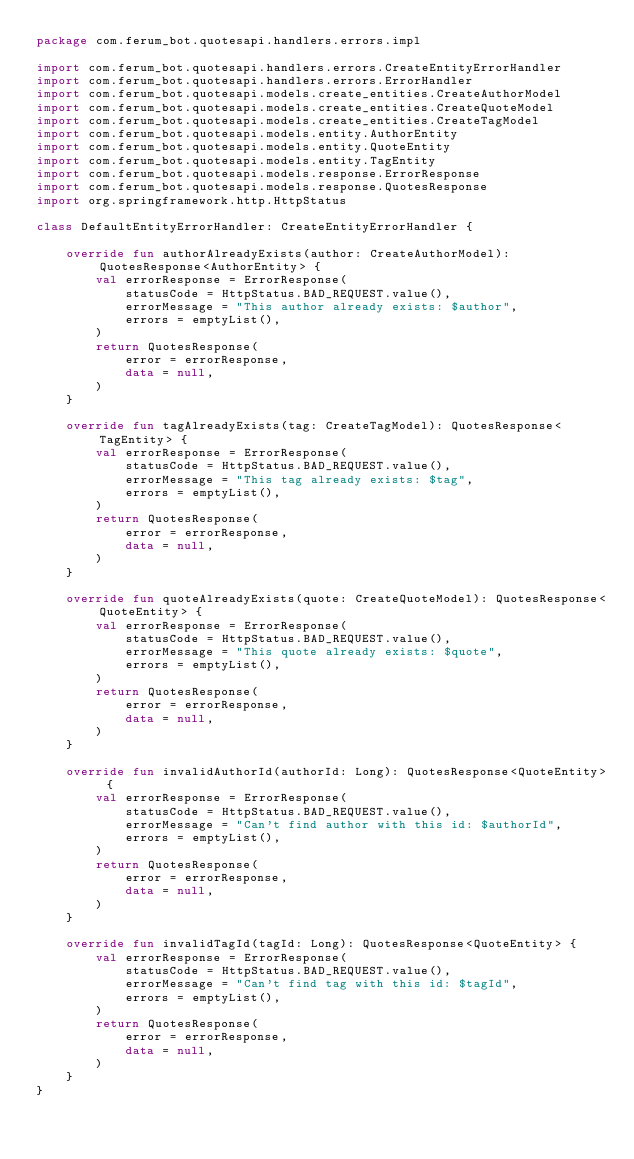Convert code to text. <code><loc_0><loc_0><loc_500><loc_500><_Kotlin_>package com.ferum_bot.quotesapi.handlers.errors.impl

import com.ferum_bot.quotesapi.handlers.errors.CreateEntityErrorHandler
import com.ferum_bot.quotesapi.handlers.errors.ErrorHandler
import com.ferum_bot.quotesapi.models.create_entities.CreateAuthorModel
import com.ferum_bot.quotesapi.models.create_entities.CreateQuoteModel
import com.ferum_bot.quotesapi.models.create_entities.CreateTagModel
import com.ferum_bot.quotesapi.models.entity.AuthorEntity
import com.ferum_bot.quotesapi.models.entity.QuoteEntity
import com.ferum_bot.quotesapi.models.entity.TagEntity
import com.ferum_bot.quotesapi.models.response.ErrorResponse
import com.ferum_bot.quotesapi.models.response.QuotesResponse
import org.springframework.http.HttpStatus

class DefaultEntityErrorHandler: CreateEntityErrorHandler {

    override fun authorAlreadyExists(author: CreateAuthorModel): QuotesResponse<AuthorEntity> {
        val errorResponse = ErrorResponse(
            statusCode = HttpStatus.BAD_REQUEST.value(),
            errorMessage = "This author already exists: $author",
            errors = emptyList(),
        )
        return QuotesResponse(
            error = errorResponse,
            data = null,
        )
    }

    override fun tagAlreadyExists(tag: CreateTagModel): QuotesResponse<TagEntity> {
        val errorResponse = ErrorResponse(
            statusCode = HttpStatus.BAD_REQUEST.value(),
            errorMessage = "This tag already exists: $tag",
            errors = emptyList(),
        )
        return QuotesResponse(
            error = errorResponse,
            data = null,
        )
    }

    override fun quoteAlreadyExists(quote: CreateQuoteModel): QuotesResponse<QuoteEntity> {
        val errorResponse = ErrorResponse(
            statusCode = HttpStatus.BAD_REQUEST.value(),
            errorMessage = "This quote already exists: $quote",
            errors = emptyList(),
        )
        return QuotesResponse(
            error = errorResponse,
            data = null,
        )
    }

    override fun invalidAuthorId(authorId: Long): QuotesResponse<QuoteEntity> {
        val errorResponse = ErrorResponse(
            statusCode = HttpStatus.BAD_REQUEST.value(),
            errorMessage = "Can't find author with this id: $authorId",
            errors = emptyList(),
        )
        return QuotesResponse(
            error = errorResponse,
            data = null,
        )
    }

    override fun invalidTagId(tagId: Long): QuotesResponse<QuoteEntity> {
        val errorResponse = ErrorResponse(
            statusCode = HttpStatus.BAD_REQUEST.value(),
            errorMessage = "Can't find tag with this id: $tagId",
            errors = emptyList(),
        )
        return QuotesResponse(
            error = errorResponse,
            data = null,
        )
    }
}</code> 